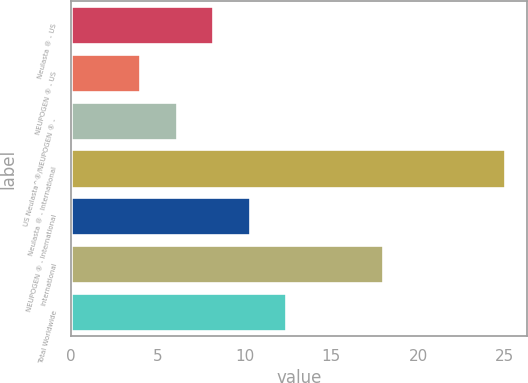<chart> <loc_0><loc_0><loc_500><loc_500><bar_chart><fcel>Neulasta ® - US<fcel>NEUPOGEN ® - US<fcel>US Neulasta^®/NEUPOGEN ® -<fcel>Neulasta ® - International<fcel>NEUPOGEN ® - International<fcel>International<fcel>Total Worldwide<nl><fcel>8.2<fcel>4<fcel>6.1<fcel>25<fcel>10.3<fcel>18<fcel>12.4<nl></chart> 